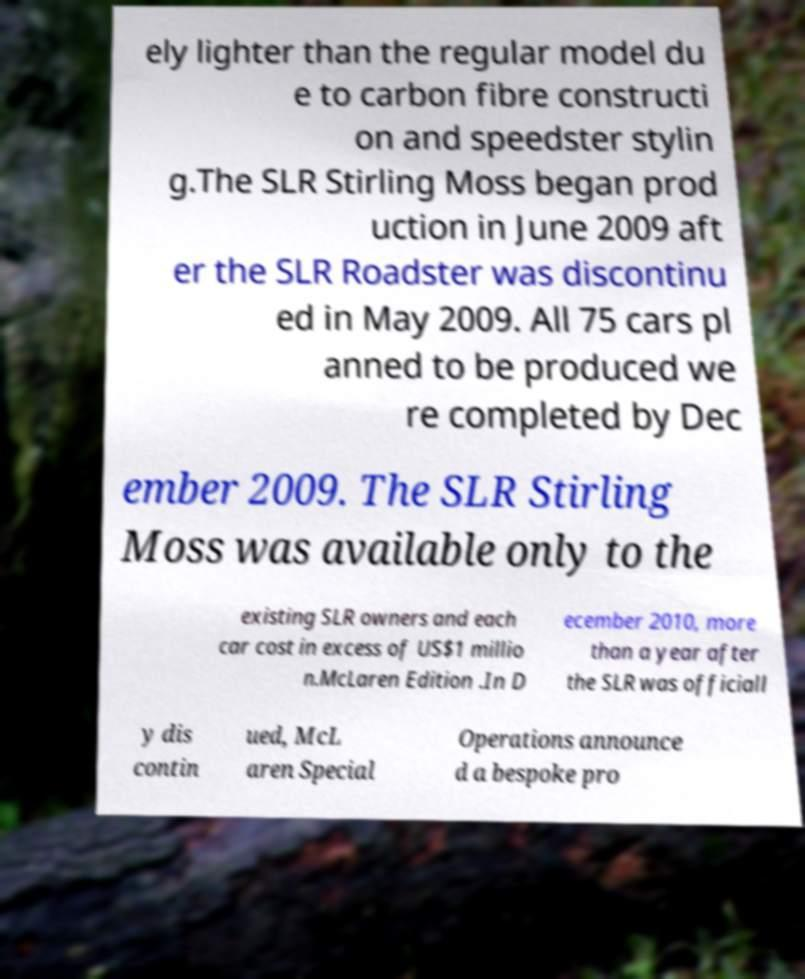Can you read and provide the text displayed in the image?This photo seems to have some interesting text. Can you extract and type it out for me? ely lighter than the regular model du e to carbon fibre constructi on and speedster stylin g.The SLR Stirling Moss began prod uction in June 2009 aft er the SLR Roadster was discontinu ed in May 2009. All 75 cars pl anned to be produced we re completed by Dec ember 2009. The SLR Stirling Moss was available only to the existing SLR owners and each car cost in excess of US$1 millio n.McLaren Edition .In D ecember 2010, more than a year after the SLR was officiall y dis contin ued, McL aren Special Operations announce d a bespoke pro 